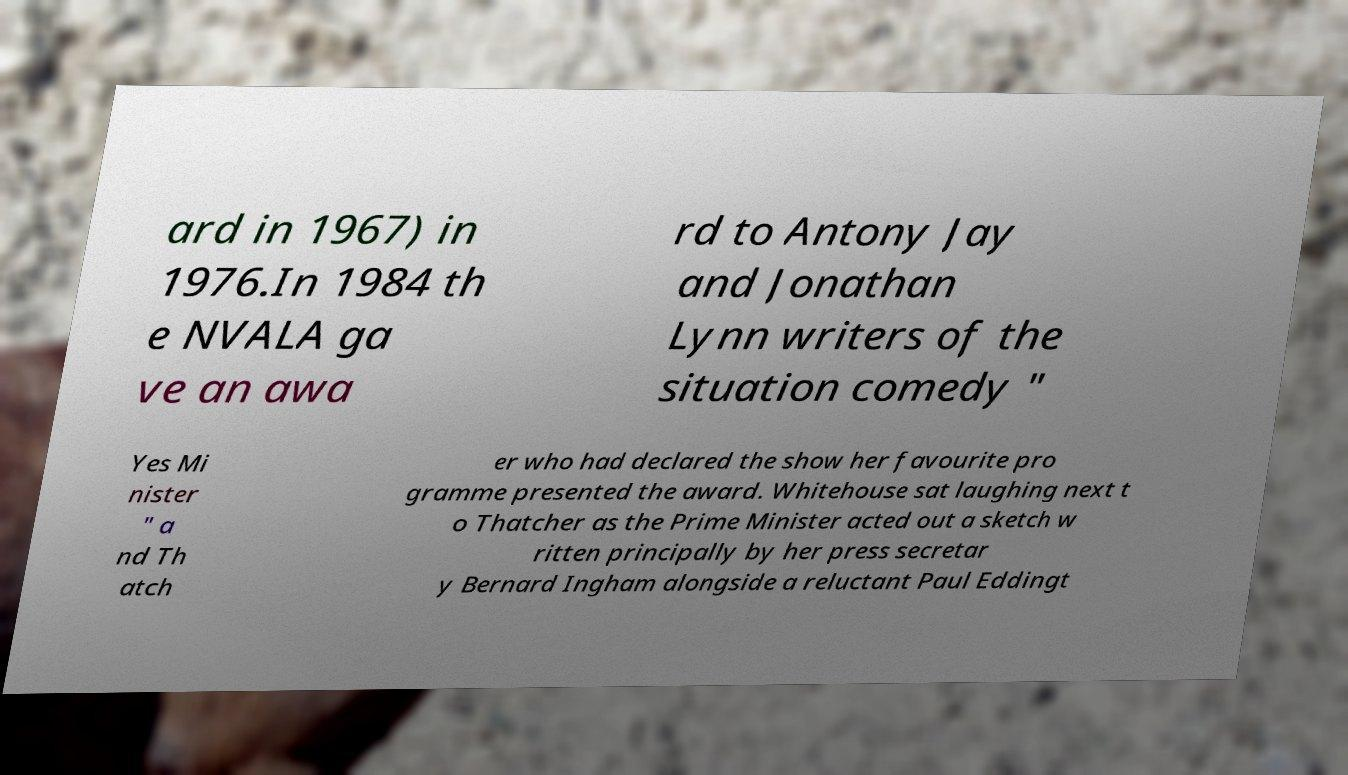What messages or text are displayed in this image? I need them in a readable, typed format. ard in 1967) in 1976.In 1984 th e NVALA ga ve an awa rd to Antony Jay and Jonathan Lynn writers of the situation comedy " Yes Mi nister " a nd Th atch er who had declared the show her favourite pro gramme presented the award. Whitehouse sat laughing next t o Thatcher as the Prime Minister acted out a sketch w ritten principally by her press secretar y Bernard Ingham alongside a reluctant Paul Eddingt 